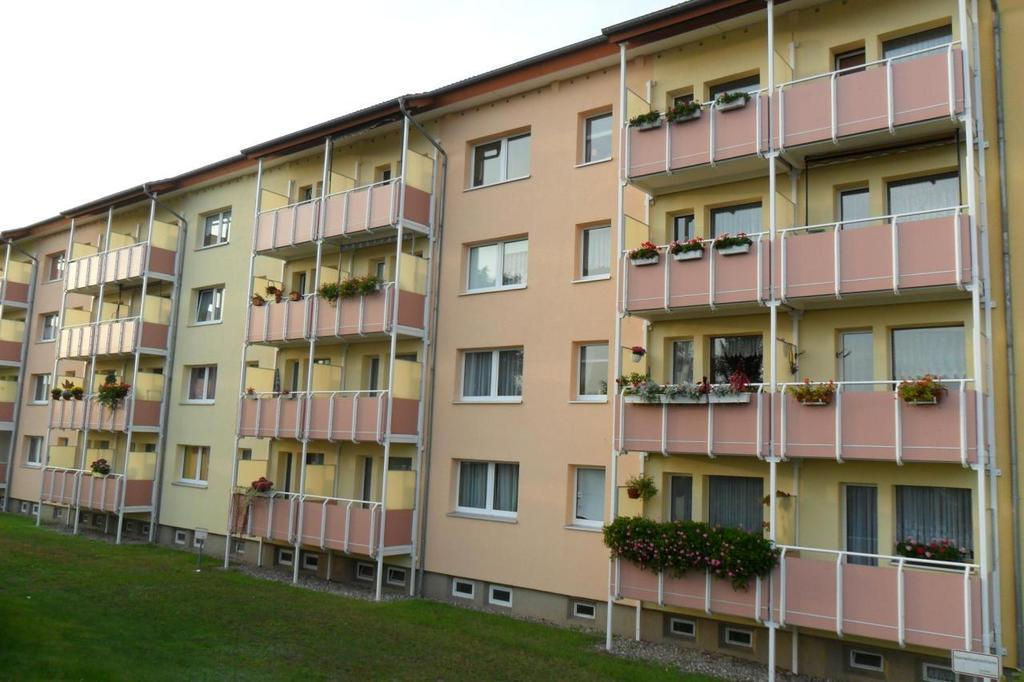What type of structures can be seen in the image? There are buildings in the image. What type of vegetation is present in the image? There are plants in the image. What is the chance of winning an instrument by taking a step in the image? There is no reference to winning an instrument or taking a step in the image, so it's not possible to answer that question. 